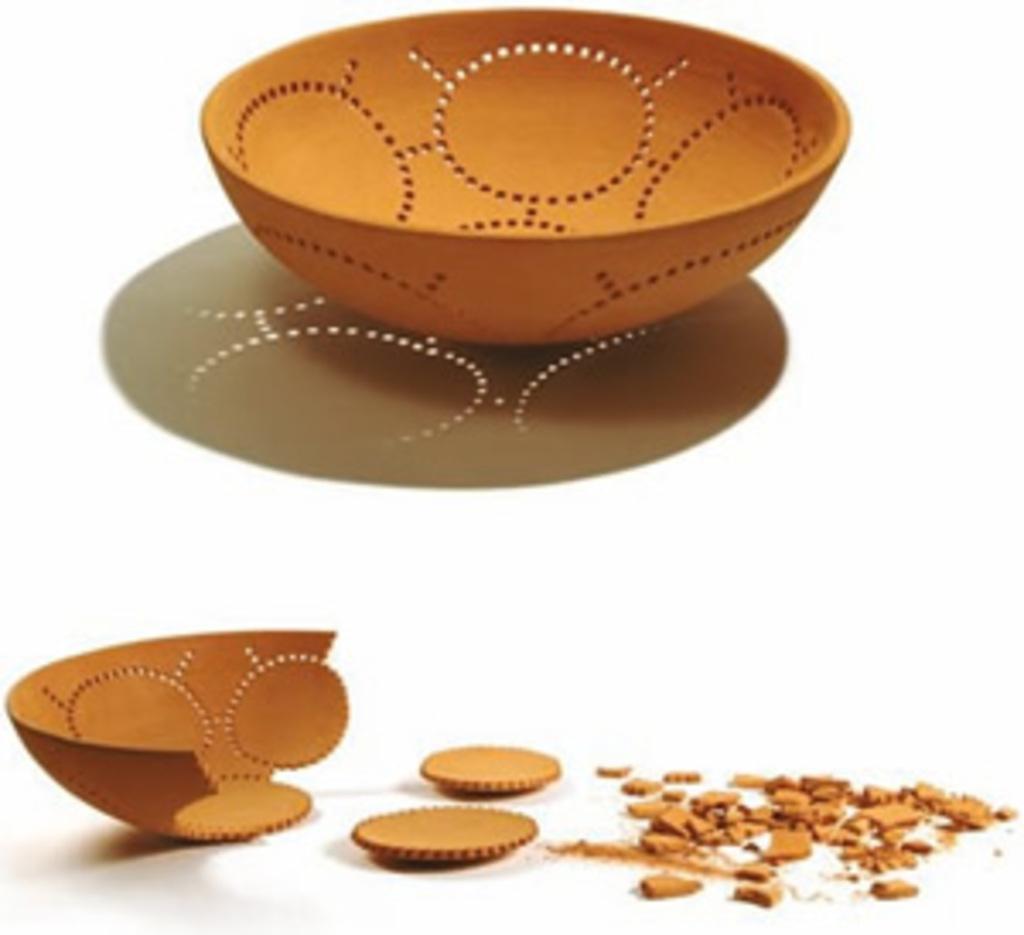Could you give a brief overview of what you see in this image? In this picture we can see a bowl and the other bowl is broken into pieces. Behind the bowls there is a white background. 